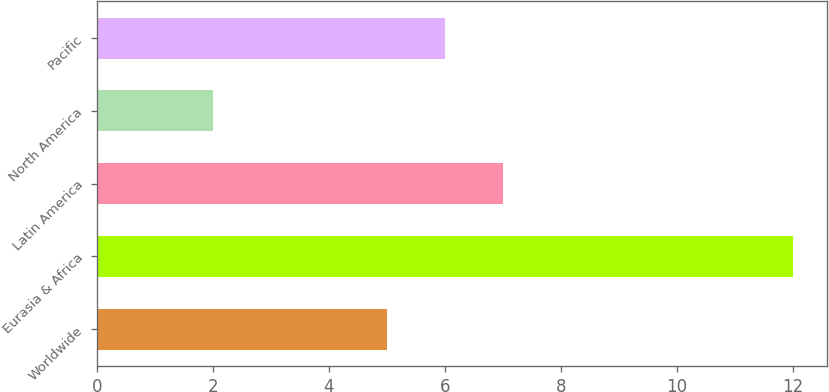Convert chart. <chart><loc_0><loc_0><loc_500><loc_500><bar_chart><fcel>Worldwide<fcel>Eurasia & Africa<fcel>Latin America<fcel>North America<fcel>Pacific<nl><fcel>5<fcel>12<fcel>7<fcel>2<fcel>6<nl></chart> 